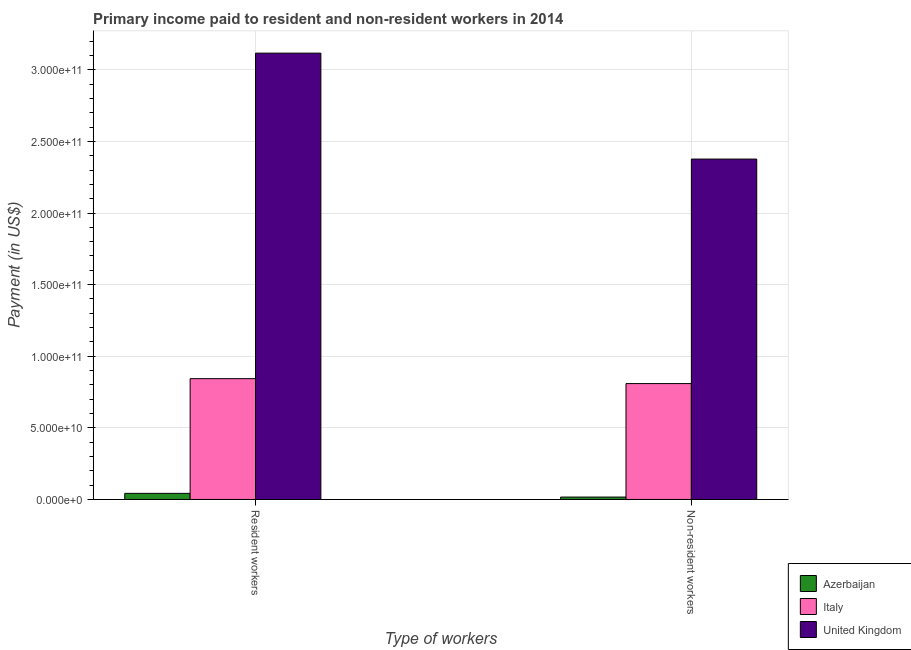How many different coloured bars are there?
Provide a succinct answer. 3. How many groups of bars are there?
Your answer should be very brief. 2. How many bars are there on the 2nd tick from the left?
Make the answer very short. 3. What is the label of the 1st group of bars from the left?
Provide a short and direct response. Resident workers. What is the payment made to non-resident workers in United Kingdom?
Make the answer very short. 2.38e+11. Across all countries, what is the maximum payment made to non-resident workers?
Offer a terse response. 2.38e+11. Across all countries, what is the minimum payment made to resident workers?
Provide a succinct answer. 4.26e+09. In which country was the payment made to non-resident workers minimum?
Your answer should be very brief. Azerbaijan. What is the total payment made to non-resident workers in the graph?
Give a very brief answer. 3.20e+11. What is the difference between the payment made to resident workers in Azerbaijan and that in Italy?
Provide a succinct answer. -8.01e+1. What is the difference between the payment made to resident workers in Azerbaijan and the payment made to non-resident workers in United Kingdom?
Provide a succinct answer. -2.33e+11. What is the average payment made to non-resident workers per country?
Your answer should be very brief. 1.07e+11. What is the difference between the payment made to resident workers and payment made to non-resident workers in Azerbaijan?
Make the answer very short. 2.58e+09. What is the ratio of the payment made to resident workers in Italy to that in United Kingdom?
Provide a succinct answer. 0.27. Is the payment made to resident workers in United Kingdom less than that in Azerbaijan?
Your response must be concise. No. What does the 1st bar from the left in Non-resident workers represents?
Ensure brevity in your answer.  Azerbaijan. What does the 3rd bar from the right in Non-resident workers represents?
Ensure brevity in your answer.  Azerbaijan. How many bars are there?
Provide a succinct answer. 6. Are all the bars in the graph horizontal?
Give a very brief answer. No. How many countries are there in the graph?
Offer a terse response. 3. What is the difference between two consecutive major ticks on the Y-axis?
Your answer should be very brief. 5.00e+1. How many legend labels are there?
Make the answer very short. 3. How are the legend labels stacked?
Ensure brevity in your answer.  Vertical. What is the title of the graph?
Provide a short and direct response. Primary income paid to resident and non-resident workers in 2014. Does "Ghana" appear as one of the legend labels in the graph?
Ensure brevity in your answer.  No. What is the label or title of the X-axis?
Make the answer very short. Type of workers. What is the label or title of the Y-axis?
Offer a very short reply. Payment (in US$). What is the Payment (in US$) of Azerbaijan in Resident workers?
Keep it short and to the point. 4.26e+09. What is the Payment (in US$) in Italy in Resident workers?
Your answer should be very brief. 8.44e+1. What is the Payment (in US$) in United Kingdom in Resident workers?
Offer a terse response. 3.12e+11. What is the Payment (in US$) of Azerbaijan in Non-resident workers?
Offer a very short reply. 1.67e+09. What is the Payment (in US$) of Italy in Non-resident workers?
Give a very brief answer. 8.09e+1. What is the Payment (in US$) of United Kingdom in Non-resident workers?
Ensure brevity in your answer.  2.38e+11. Across all Type of workers, what is the maximum Payment (in US$) of Azerbaijan?
Make the answer very short. 4.26e+09. Across all Type of workers, what is the maximum Payment (in US$) of Italy?
Ensure brevity in your answer.  8.44e+1. Across all Type of workers, what is the maximum Payment (in US$) in United Kingdom?
Provide a succinct answer. 3.12e+11. Across all Type of workers, what is the minimum Payment (in US$) of Azerbaijan?
Keep it short and to the point. 1.67e+09. Across all Type of workers, what is the minimum Payment (in US$) of Italy?
Your answer should be compact. 8.09e+1. Across all Type of workers, what is the minimum Payment (in US$) in United Kingdom?
Keep it short and to the point. 2.38e+11. What is the total Payment (in US$) of Azerbaijan in the graph?
Your answer should be very brief. 5.93e+09. What is the total Payment (in US$) in Italy in the graph?
Ensure brevity in your answer.  1.65e+11. What is the total Payment (in US$) of United Kingdom in the graph?
Give a very brief answer. 5.49e+11. What is the difference between the Payment (in US$) in Azerbaijan in Resident workers and that in Non-resident workers?
Your answer should be compact. 2.58e+09. What is the difference between the Payment (in US$) in Italy in Resident workers and that in Non-resident workers?
Ensure brevity in your answer.  3.45e+09. What is the difference between the Payment (in US$) in United Kingdom in Resident workers and that in Non-resident workers?
Make the answer very short. 7.40e+1. What is the difference between the Payment (in US$) in Azerbaijan in Resident workers and the Payment (in US$) in Italy in Non-resident workers?
Your answer should be very brief. -7.67e+1. What is the difference between the Payment (in US$) of Azerbaijan in Resident workers and the Payment (in US$) of United Kingdom in Non-resident workers?
Offer a very short reply. -2.33e+11. What is the difference between the Payment (in US$) in Italy in Resident workers and the Payment (in US$) in United Kingdom in Non-resident workers?
Offer a very short reply. -1.53e+11. What is the average Payment (in US$) of Azerbaijan per Type of workers?
Make the answer very short. 2.96e+09. What is the average Payment (in US$) of Italy per Type of workers?
Your answer should be very brief. 8.26e+1. What is the average Payment (in US$) in United Kingdom per Type of workers?
Your response must be concise. 2.75e+11. What is the difference between the Payment (in US$) in Azerbaijan and Payment (in US$) in Italy in Resident workers?
Ensure brevity in your answer.  -8.01e+1. What is the difference between the Payment (in US$) of Azerbaijan and Payment (in US$) of United Kingdom in Resident workers?
Give a very brief answer. -3.07e+11. What is the difference between the Payment (in US$) of Italy and Payment (in US$) of United Kingdom in Resident workers?
Provide a succinct answer. -2.27e+11. What is the difference between the Payment (in US$) of Azerbaijan and Payment (in US$) of Italy in Non-resident workers?
Provide a short and direct response. -7.92e+1. What is the difference between the Payment (in US$) of Azerbaijan and Payment (in US$) of United Kingdom in Non-resident workers?
Your answer should be very brief. -2.36e+11. What is the difference between the Payment (in US$) of Italy and Payment (in US$) of United Kingdom in Non-resident workers?
Make the answer very short. -1.57e+11. What is the ratio of the Payment (in US$) of Azerbaijan in Resident workers to that in Non-resident workers?
Your answer should be compact. 2.54. What is the ratio of the Payment (in US$) of Italy in Resident workers to that in Non-resident workers?
Your answer should be compact. 1.04. What is the ratio of the Payment (in US$) in United Kingdom in Resident workers to that in Non-resident workers?
Your response must be concise. 1.31. What is the difference between the highest and the second highest Payment (in US$) in Azerbaijan?
Offer a terse response. 2.58e+09. What is the difference between the highest and the second highest Payment (in US$) of Italy?
Keep it short and to the point. 3.45e+09. What is the difference between the highest and the second highest Payment (in US$) of United Kingdom?
Your answer should be very brief. 7.40e+1. What is the difference between the highest and the lowest Payment (in US$) in Azerbaijan?
Provide a short and direct response. 2.58e+09. What is the difference between the highest and the lowest Payment (in US$) of Italy?
Keep it short and to the point. 3.45e+09. What is the difference between the highest and the lowest Payment (in US$) in United Kingdom?
Provide a short and direct response. 7.40e+1. 